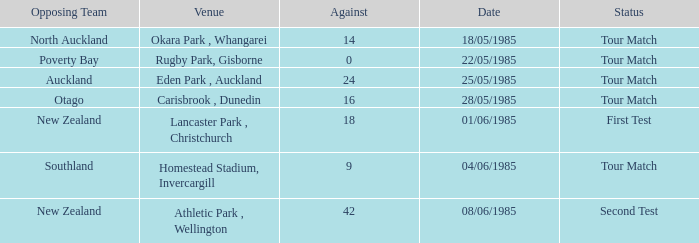Which opposing team had an Against score less than 42 and a Tour Match status in Rugby Park, Gisborne? Poverty Bay. 